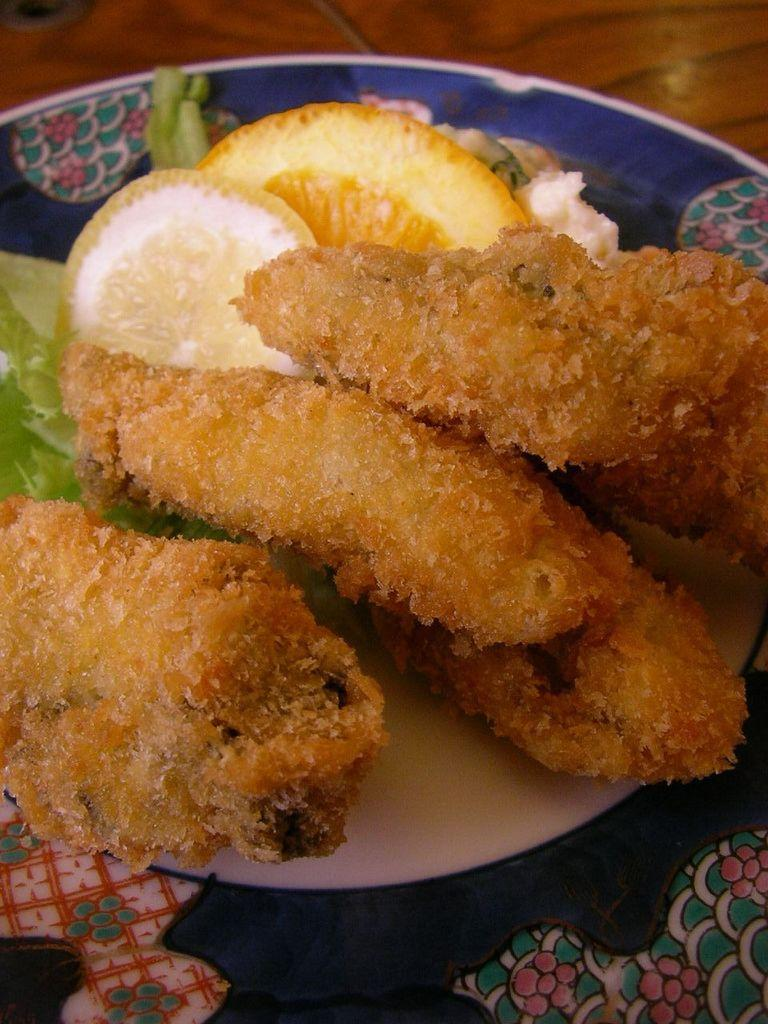What object is present on the table in the image? There is a plate in the image. What is on the plate? The plate contains food. Where is the plate located? The plate is placed on a table. What type of shirt is being worn by the food on the plate? There is no shirt present in the image, as the subject is food on a plate. 